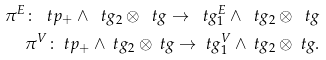<formula> <loc_0><loc_0><loc_500><loc_500>\pi ^ { E } \colon \ t p _ { + } \wedge \ t g _ { 2 } \otimes \ t g \to \ t g _ { 1 } ^ { E } \wedge \ t g _ { 2 } \otimes \ t g \\ \pi ^ { V } \colon \ t p _ { + } \wedge \ t g _ { 2 } \otimes \ t g \to \ t g _ { 1 } ^ { V } \wedge \ t g _ { 2 } \otimes \ t g .</formula> 